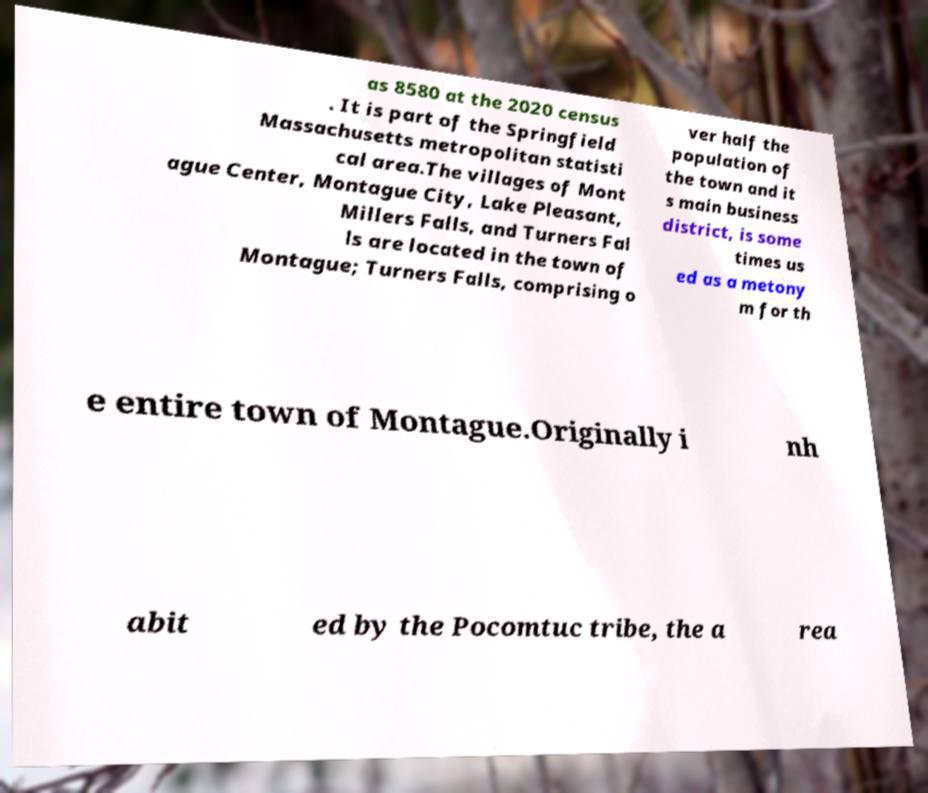For documentation purposes, I need the text within this image transcribed. Could you provide that? as 8580 at the 2020 census . It is part of the Springfield Massachusetts metropolitan statisti cal area.The villages of Mont ague Center, Montague City, Lake Pleasant, Millers Falls, and Turners Fal ls are located in the town of Montague; Turners Falls, comprising o ver half the population of the town and it s main business district, is some times us ed as a metony m for th e entire town of Montague.Originally i nh abit ed by the Pocomtuc tribe, the a rea 